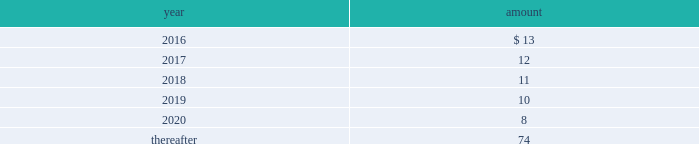Long-term liabilities .
The value of the company 2019s deferred compensation obligations is based on the market value of the participants 2019 notional investment accounts .
The notional investments are comprised primarily of mutual funds , which are based on observable market prices .
Mark-to-market derivative asset and liability 2014the company utilizes fixed-to-floating interest-rate swaps , typically designated as fair-value hedges , to achieve a targeted level of variable-rate debt as a percentage of total debt .
The company also employs derivative financial instruments in the form of variable-to-fixed interest rate swaps , classified as economic hedges , in order to fix the interest cost on some of its variable-rate debt .
The company uses a calculation of future cash inflows and estimated future outflows , which are discounted , to determine the current fair value .
Additional inputs to the present value calculation include the contract terms , counterparty credit risk , interest rates and market volatility .
Other investments 2014other investments primarily represent money market funds used for active employee benefits .
The company includes other investments in other current assets .
Note 18 : leases the company has entered into operating leases involving certain facilities and equipment .
Rental expenses under operating leases were $ 21 for 2015 , $ 22 for 2014 and $ 23 for 2013 .
The operating leases for facilities will expire over the next 25 years and the operating leases for equipment will expire over the next five years .
Certain operating leases have renewal options ranging from one to five years .
The minimum annual future rental commitment under operating leases that have initial or remaining non- cancelable lease terms over the next five years and thereafter are as follows: .
The company has a series of agreements with various public entities ( the 201cpartners 201d ) to establish certain joint ventures , commonly referred to as 201cpublic-private partnerships . 201d under the public-private partnerships , the company constructed utility plant , financed by the company and the partners constructed utility plant ( connected to the company 2019s property ) , financed by the partners .
The company agreed to transfer and convey some of its real and personal property to the partners in exchange for an equal principal amount of industrial development bonds ( 201cidbs 201d ) , issued by the partners under a state industrial development bond and commercial development act .
The company leased back the total facilities , including portions funded by both the company and the partners , under leases for a period of 40 years .
The leases related to the portion of the facilities funded by the company have required payments from the company to the partners that approximate the payments required by the terms of the idbs from the partners to the company ( as the holder of the idbs ) .
As the ownership of the portion of the facilities constructed by the company will revert back to the company at the end of the lease , the company has recorded these as capital leases .
The lease obligation and the receivable for the principal amount of the idbs are presented by the company on a net basis .
The gross cost of the facilities funded by the company recognized as a capital lease asset was $ 156 and $ 157 as of december 31 , 2015 and 2014 , respectively , which is presented in property , plant and equipment in the accompanying consolidated balance sheets .
The future payments under the lease obligations are equal to and offset by the payments receivable under the idbs. .
What percentage does rental expense make up of gross cost of facilities funded in 2015? 
Computations: (21 / 156)
Answer: 0.13462. 